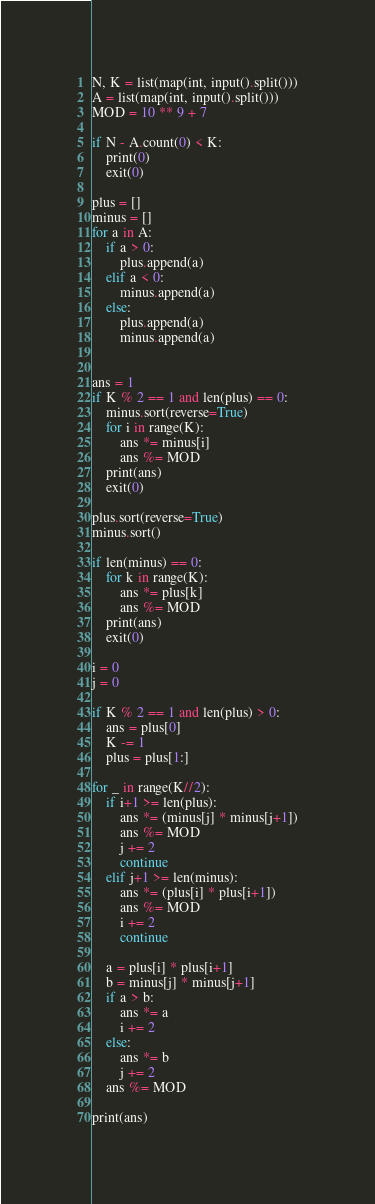<code> <loc_0><loc_0><loc_500><loc_500><_Python_>N, K = list(map(int, input().split()))
A = list(map(int, input().split()))
MOD = 10 ** 9 + 7

if N - A.count(0) < K:
    print(0)
    exit(0)

plus = []
minus = []
for a in A:
    if a > 0:
        plus.append(a)
    elif a < 0:
        minus.append(a)
    else:
        plus.append(a)
        minus.append(a)


ans = 1
if K % 2 == 1 and len(plus) == 0:
    minus.sort(reverse=True)
    for i in range(K):
        ans *= minus[i]
        ans %= MOD
    print(ans)
    exit(0)

plus.sort(reverse=True)
minus.sort()

if len(minus) == 0:
    for k in range(K):
        ans *= plus[k]
        ans %= MOD
    print(ans)
    exit(0)

i = 0
j = 0

if K % 2 == 1 and len(plus) > 0:
    ans = plus[0]
    K -= 1
    plus = plus[1:]

for _ in range(K//2):
    if i+1 >= len(plus):
        ans *= (minus[j] * minus[j+1])
        ans %= MOD
        j += 2
        continue
    elif j+1 >= len(minus):
        ans *= (plus[i] * plus[i+1])
        ans %= MOD
        i += 2
        continue

    a = plus[i] * plus[i+1]
    b = minus[j] * minus[j+1]
    if a > b:
        ans *= a
        i += 2
    else:
        ans *= b
        j += 2
    ans %= MOD

print(ans)
</code> 